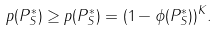<formula> <loc_0><loc_0><loc_500><loc_500>p ( P _ { S } ^ { * } ) \geq p ( P _ { S } ^ { * } ) = ( 1 - \phi ( P _ { S } ^ { * } ) ) ^ { K } .</formula> 